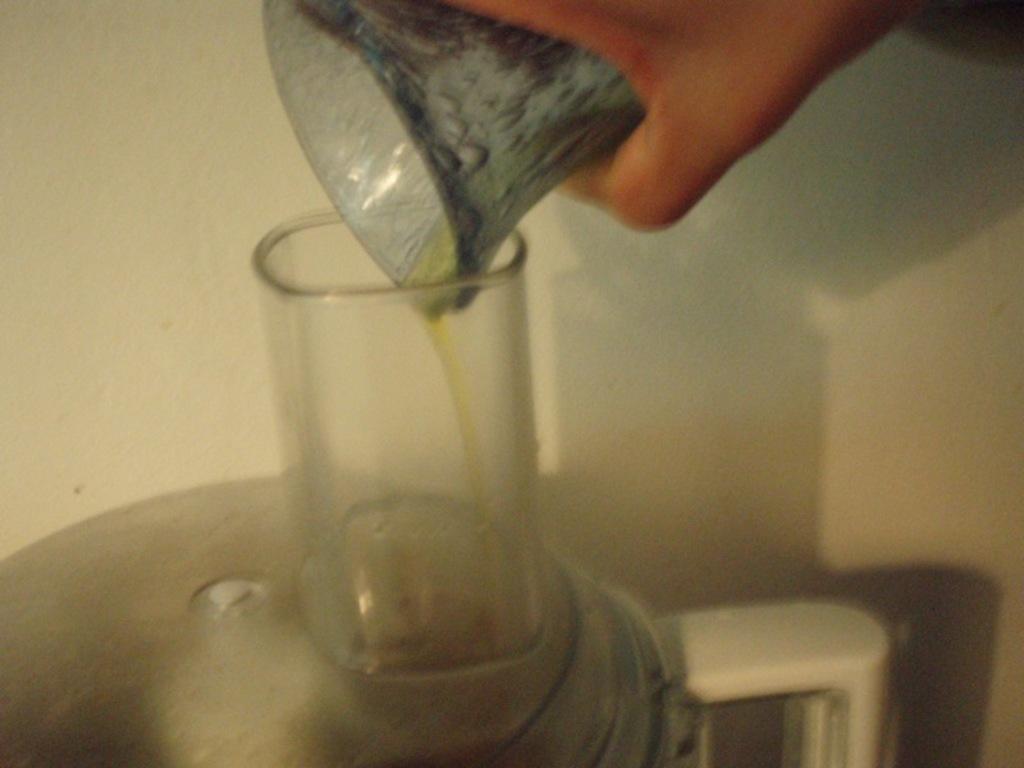How would you summarize this image in a sentence or two? In this image we can see hand of a person holding an object. Here we can see a jar and a glass. In the background there is a wall. 